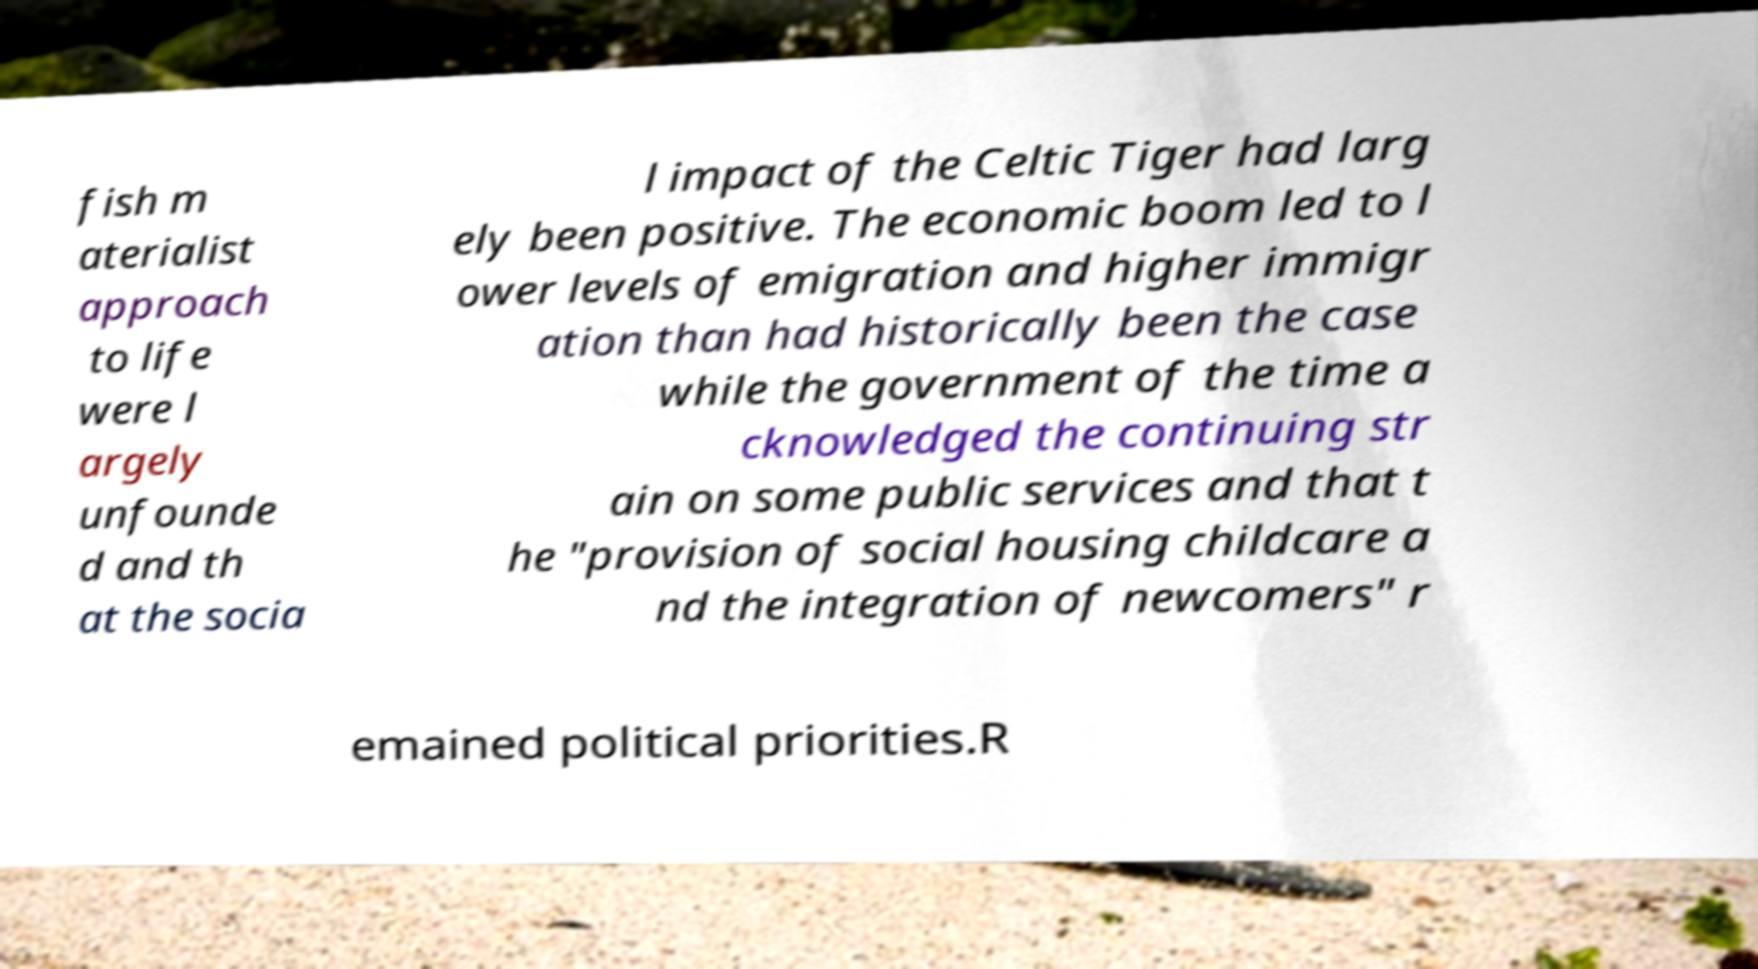What messages or text are displayed in this image? I need them in a readable, typed format. fish m aterialist approach to life were l argely unfounde d and th at the socia l impact of the Celtic Tiger had larg ely been positive. The economic boom led to l ower levels of emigration and higher immigr ation than had historically been the case while the government of the time a cknowledged the continuing str ain on some public services and that t he "provision of social housing childcare a nd the integration of newcomers" r emained political priorities.R 